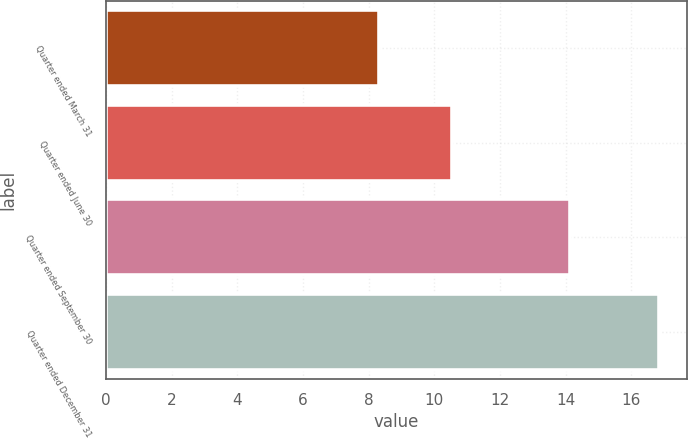<chart> <loc_0><loc_0><loc_500><loc_500><bar_chart><fcel>Quarter ended March 31<fcel>Quarter ended June 30<fcel>Quarter ended September 30<fcel>Quarter ended December 31<nl><fcel>8.33<fcel>10.55<fcel>14.14<fcel>16.85<nl></chart> 